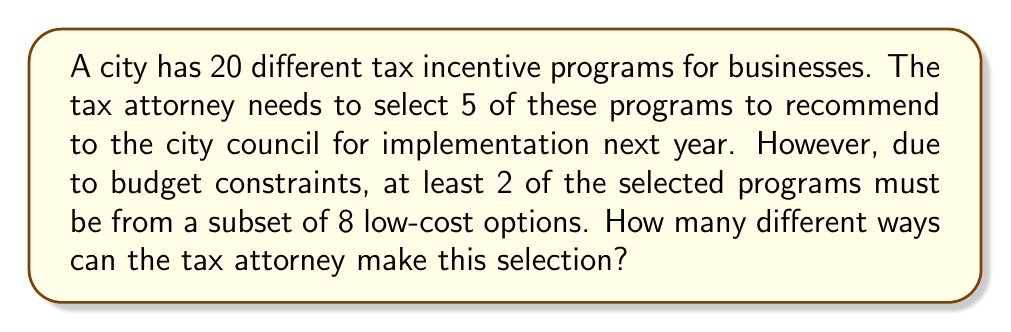Teach me how to tackle this problem. Let's approach this step-by-step using combinatorics:

1) First, we need to select at least 2 programs from the 8 low-cost options. We can break this down into three cases:

   Case 1: Select 2 from low-cost, 3 from others
   Case 2: Select 3 from low-cost, 2 from others
   Case 3: Select 4 from low-cost, 1 from others
   Case 4: Select all 5 from low-cost

2) Let's calculate each case:

   Case 1: $\binom{8}{2} \times \binom{12}{3}$
   Case 2: $\binom{8}{3} \times \binom{12}{2}$
   Case 3: $\binom{8}{4} \times \binom{12}{1}$
   Case 4: $\binom{8}{5}$

3) Now, let's calculate each combination:

   $\binom{8}{2} = \frac{8!}{2!(8-2)!} = \frac{8 \times 7}{2 \times 1} = 28$
   $\binom{12}{3} = \frac{12!}{3!(12-3)!} = \frac{12 \times 11 \times 10}{3 \times 2 \times 1} = 220$
   $\binom{8}{3} = \frac{8!}{3!(8-3)!} = \frac{8 \times 7 \times 6}{3 \times 2 \times 1} = 56$
   $\binom{12}{2} = \frac{12!}{2!(12-2)!} = \frac{12 \times 11}{2 \times 1} = 66$
   $\binom{8}{4} = \frac{8!}{4!(8-4)!} = \frac{8 \times 7 \times 6 \times 5}{4 \times 3 \times 2 \times 1} = 70$
   $\binom{12}{1} = 12$
   $\binom{8}{5} = \frac{8!}{5!(8-5)!} = \frac{8 \times 7 \times 6 \times 5 \times 4}{5 \times 4 \times 3 \times 2 \times 1} = 56$

4) Now, we sum up all the cases:

   Case 1: $28 \times 220 = 6,160$
   Case 2: $56 \times 66 = 3,696$
   Case 3: $70 \times 12 = 840$
   Case 4: $56$

5) Total number of ways = $6,160 + 3,696 + 840 + 56 = 10,752$

Therefore, the tax attorney can make this selection in 10,752 different ways.
Answer: 10,752 